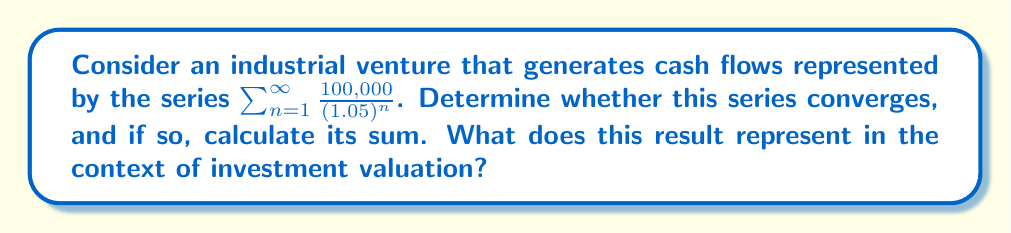Teach me how to tackle this problem. To analyze the convergence of this series and calculate its sum, we'll follow these steps:

1) First, recognize that this is a geometric series with first term $a = 100,000$ and common ratio $r = \frac{1}{1.05}$.

2) For a geometric series $\sum_{n=1}^{\infty} ar^{n-1}$, we know that it converges if and only if $|r| < 1$.

3) In this case, $r = \frac{1}{1.05} \approx 0.9524$, which is less than 1. Therefore, the series converges.

4) For a convergent geometric series, the sum is given by the formula:

   $$S_{\infty} = \frac{a}{1-r}$$

   where $a$ is the first term and $r$ is the common ratio.

5) Substituting our values:

   $$S_{\infty} = \frac{100,000}{1-\frac{1}{1.05}} = \frac{100,000}{\frac{0.05}{1.05}} = 100,000 \cdot \frac{1.05}{0.05} = 2,100,000$$

6) In the context of investment valuation, this result represents the present value of an infinite stream of cash flows, where each year's cash flow is 5% smaller than the previous year's, starting with $100,000 in the first year.

7) This is equivalent to the valuation of a perpetuity (an investment that provides a constant stream of cash flows indefinitely) with a growth rate. The initial cash flow is $100,000, the discount rate is 5% (as seen in the denominator (1.05)), and the implied negative growth rate is also 5% (as each term is 1/1.05 times the previous term).

8) The formula for a growing perpetuity is $\frac{CF_1}{r-g}$, where $CF_1$ is the first cash flow, $r$ is the discount rate, and $g$ is the growth rate. In this case, $CF_1 = 100,000$, $r = 0.05$, and $g = -0.05$, which yields the same result: $\frac{100,000}{0.05-(-0.05)} = 2,100,000$.
Answer: The series converges to $2,100,000. This represents the present value of an infinite stream of cash flows from the industrial venture, starting at $100,000 and decreasing by 5% each year, discounted at a 5% rate. 